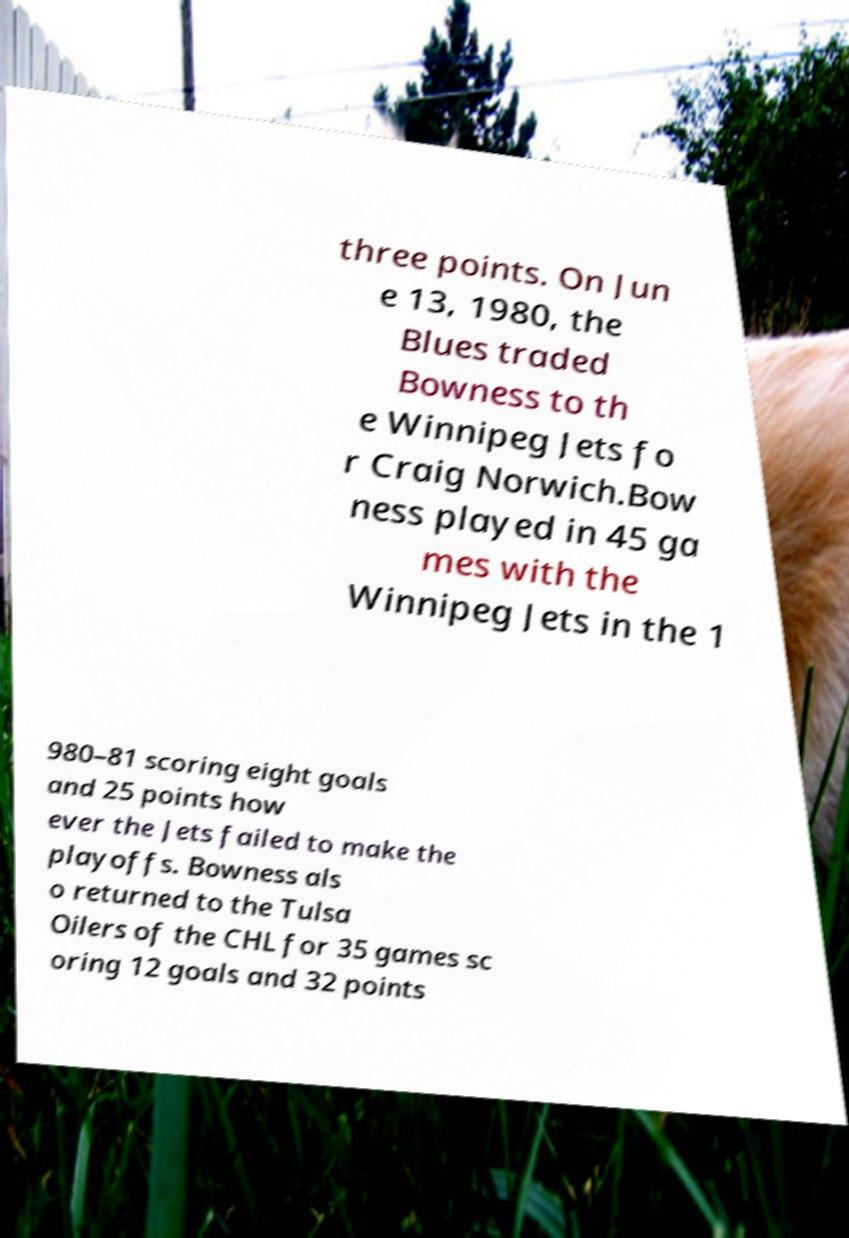Could you extract and type out the text from this image? three points. On Jun e 13, 1980, the Blues traded Bowness to th e Winnipeg Jets fo r Craig Norwich.Bow ness played in 45 ga mes with the Winnipeg Jets in the 1 980–81 scoring eight goals and 25 points how ever the Jets failed to make the playoffs. Bowness als o returned to the Tulsa Oilers of the CHL for 35 games sc oring 12 goals and 32 points 